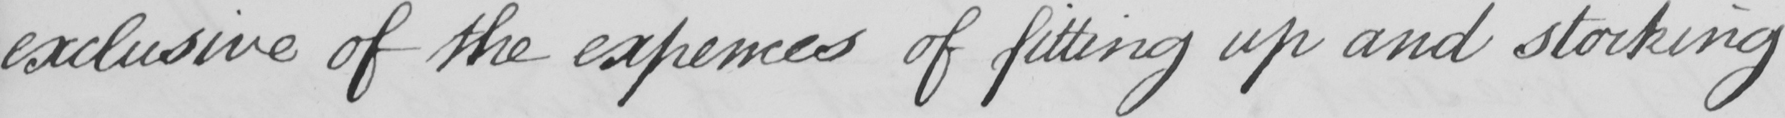What text is written in this handwritten line? exclusive of the expences of fitting up and stocking 